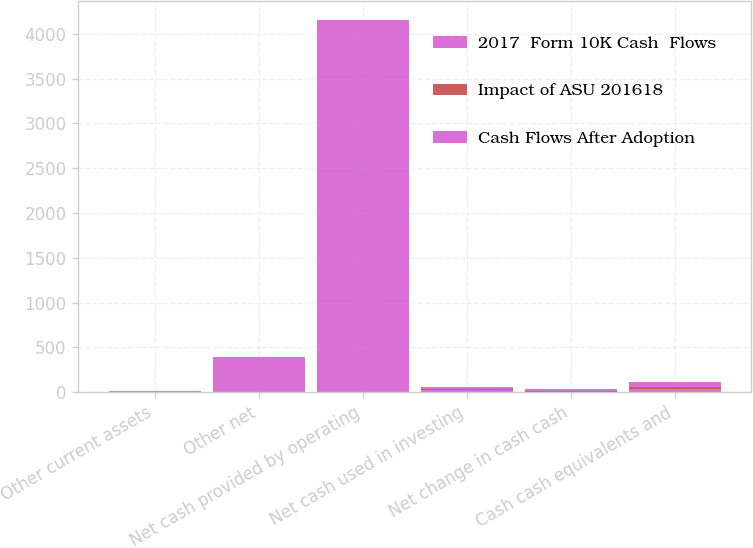<chart> <loc_0><loc_0><loc_500><loc_500><stacked_bar_chart><ecel><fcel>Other current assets<fcel>Other net<fcel>Net cash provided by operating<fcel>Net cash used in investing<fcel>Net change in cash cash<fcel>Cash cash equivalents and<nl><fcel>2017  Form 10K Cash  Flows<fcel>6<fcel>197.5<fcel>2079.6<fcel>19.7<fcel>1.4<fcel>38.9<nl><fcel>Impact of ASU 201618<fcel>1.1<fcel>0.1<fcel>1<fcel>14.5<fcel>15.5<fcel>19.7<nl><fcel>Cash Flows After Adoption<fcel>7.1<fcel>197.4<fcel>2078.6<fcel>19.7<fcel>14.1<fcel>58.6<nl></chart> 